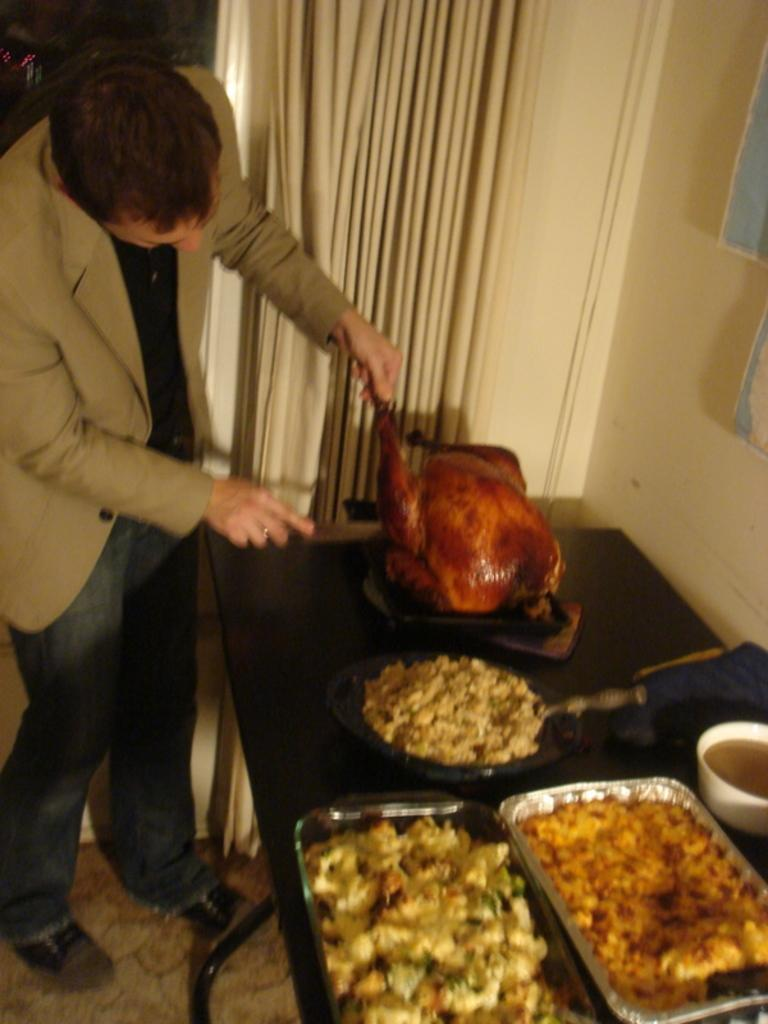What is the man doing on the left side of the image? The man is standing on the left side of the image. What is the man holding in his left hand? The man is holding a chicken in his left hand. What type of clothing is the man wearing? The man is wearing a coat and trousers. What can be seen on the right side of the image? There is a curtain on the right side of the image. What type of noise is the chicken making in the image? The image does not provide any information about the noise the chicken might be making. 